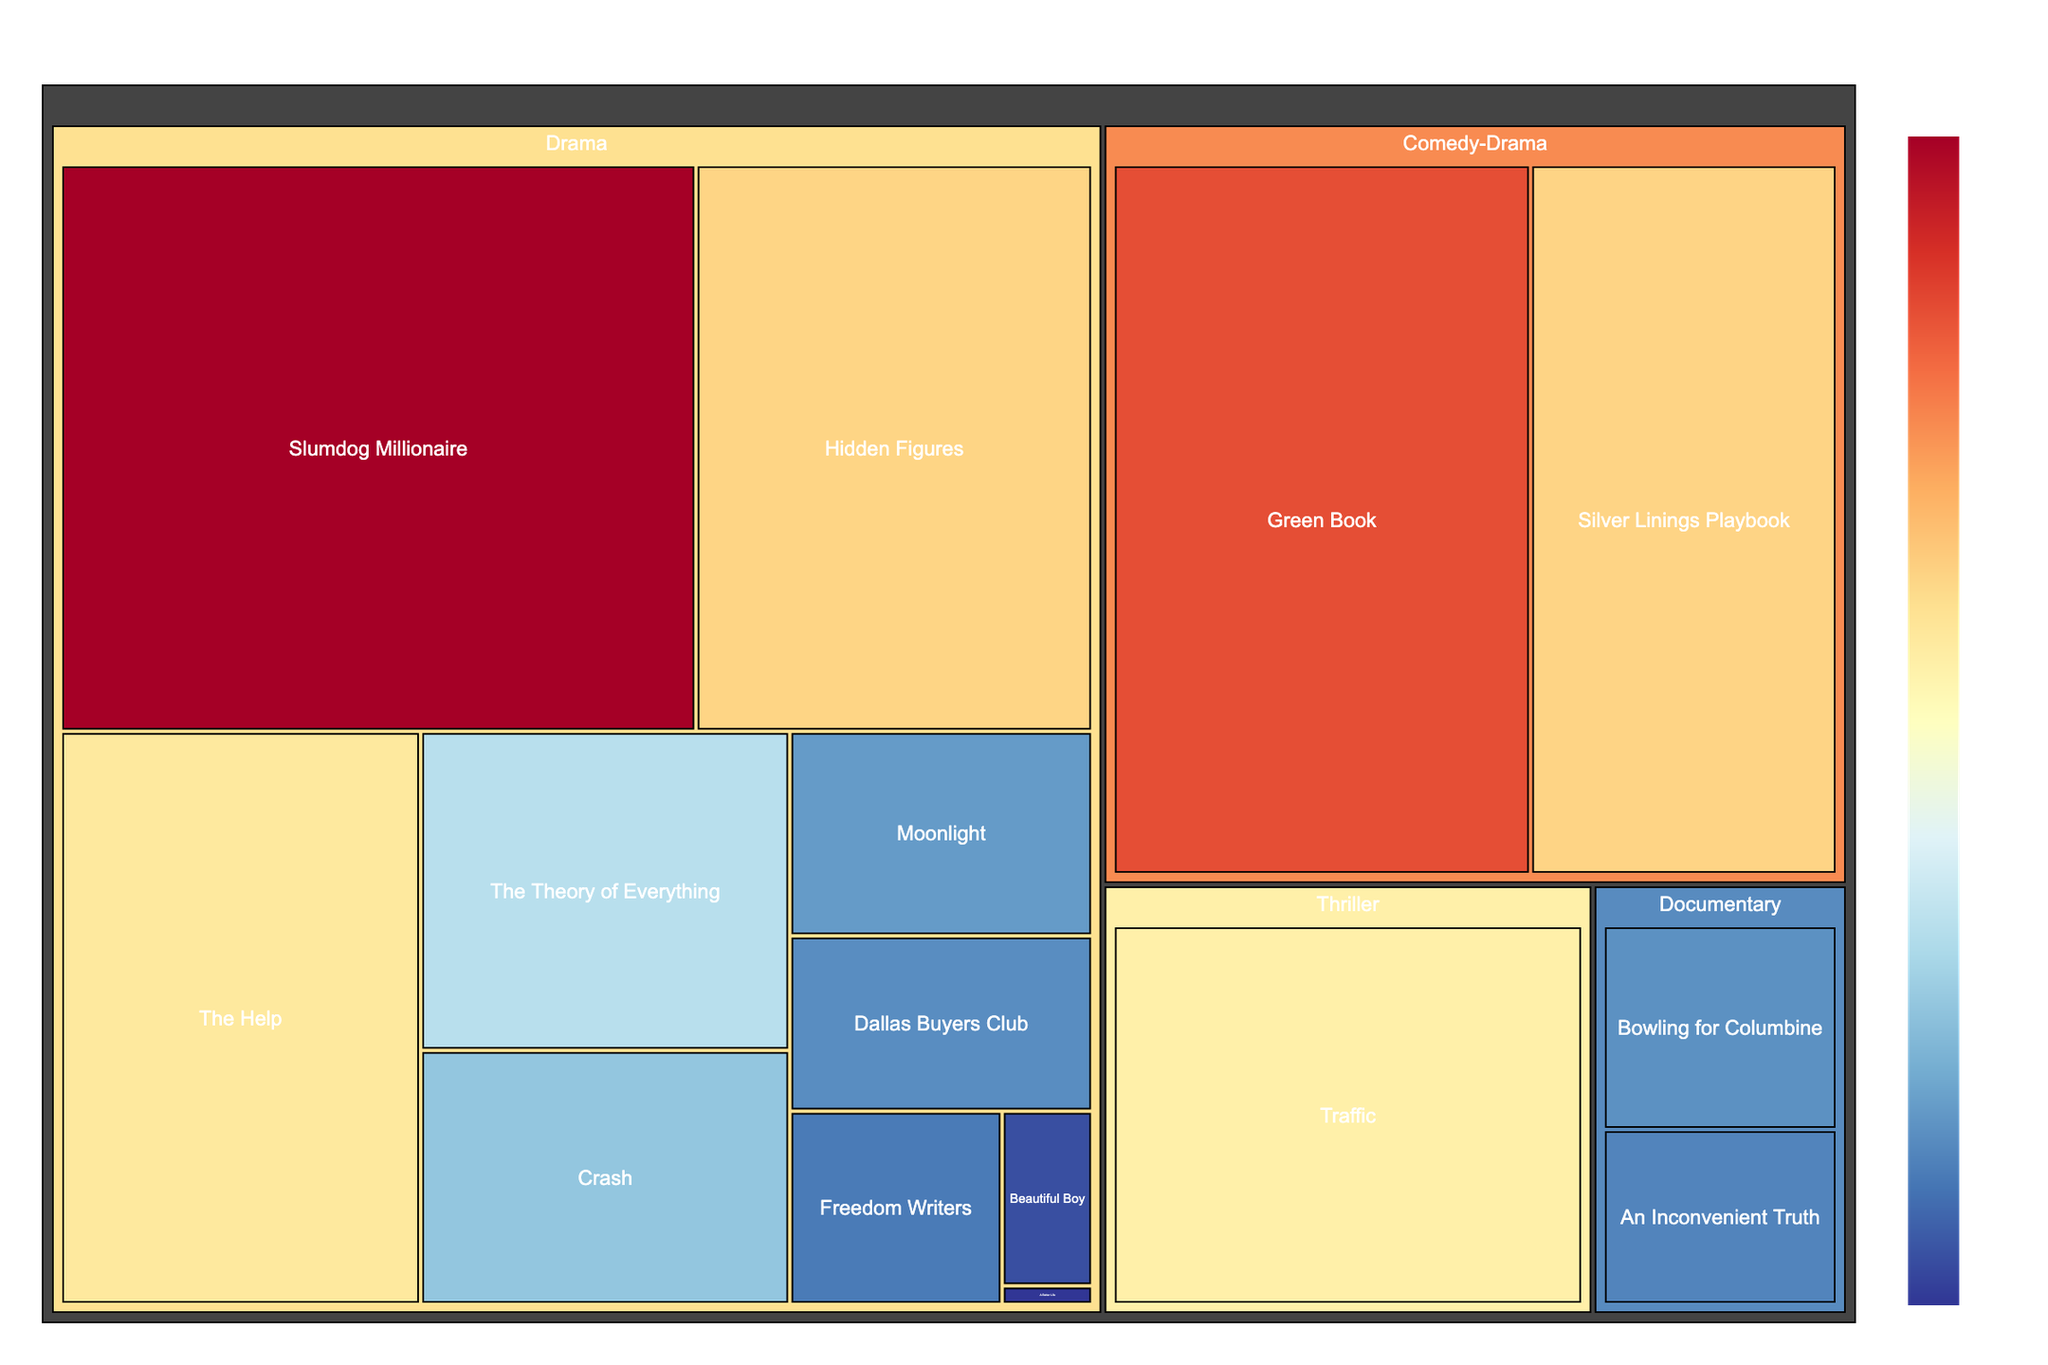What is the box office revenue of the film "Traffic"? Look at the treemap and find the rectangle labeled "Traffic" under the "Thriller" genre. The revenue value is displayed within the rectangle.
Answer: $207,515,725 Which film has the highest revenue in the "Drama" genre? Look at the rectangles under the "Drama" genre and identify the one with the highest revenue value. The film with the highest revenue is "Slumdog Millionaire" with $377,910,544.
Answer: Slumdog Millionaire What is the combined revenue of all films in the "Documentary" genre? Add the revenue values of the films labeled under the "Documentary" genre: "An Inconvenient Truth" ($49,756,507) and "Bowling for Columbine" ($58,008,423). The sum is $107,764,930.
Answer: $107,764,930 How does the revenue of "The Help" compare to "Silver Linings Playbook"? Look at the revenue values for "The Help" ($216,639,112) and "Silver Linings Playbook" ($236,412,453) and compare them. "Silver Linings Playbook" has a higher revenue.
Answer: Silver Linings Playbook What is the total revenue for films categorized under "Social Justice"? Identify the films under the "Social Justice" category. "The Help" is the only film, and its revenue is $216,639,112.
Answer: $216,639,112 How many films are in the "Drama" genre? Count all the rectangles under the "Drama" genre. There are 10 films in the "Drama" genre.
Answer: 10 Which film represents the environmental category, and what is its revenue? Find the film labeled under the "Environmental" category, which is "An Inconvenient Truth," and its revenue is $49,756,507.
Answer: An Inconvenient Truth, $49,756,507 Does the "Comedy-Drama" genre have any films with revenue greater than $200 million? Look at the films under the "Comedy-Drama" genre and check their revenue. "Silver Linings Playbook" ($236,412,453) and "Green Book" ($321,752,656) both have revenue greater than $200 million.
Answer: Yes What is the average revenue of films in the "Drama" genre? Add the revenues of all films in the "Drama" genre and divide by the number of films. Total revenue = $216,639,112 + $377,910,544 + $98,410,061 + $65,046,687 + $55,736,588 + $235,956,898 + $1,759,252 + $123,726,688 + $43,090,741 + $16,620,201 = $1,234,896,772. Number of films = 10. Average revenue = $1,234,896,772 / 10 = $123,489,677.20.
Answer: $123,489,677.20 